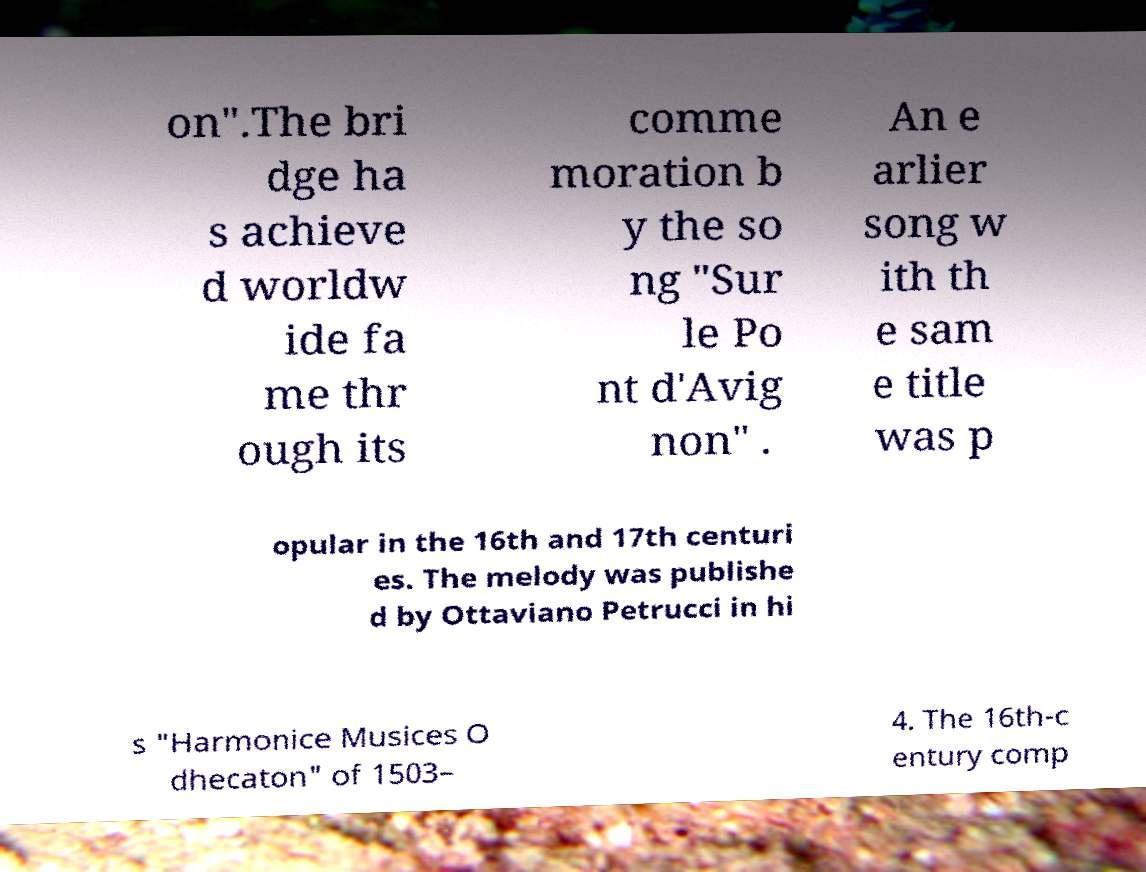Can you accurately transcribe the text from the provided image for me? on".The bri dge ha s achieve d worldw ide fa me thr ough its comme moration b y the so ng "Sur le Po nt d'Avig non" . An e arlier song w ith th e sam e title was p opular in the 16th and 17th centuri es. The melody was publishe d by Ottaviano Petrucci in hi s "Harmonice Musices O dhecaton" of 1503– 4. The 16th-c entury comp 